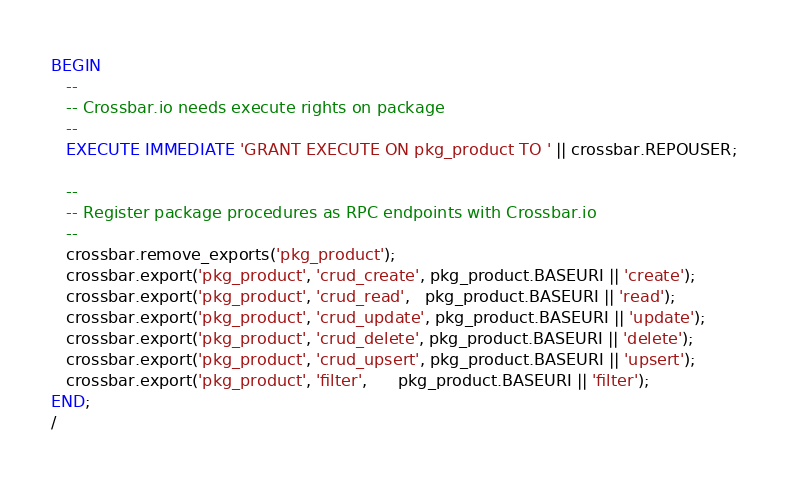<code> <loc_0><loc_0><loc_500><loc_500><_SQL_>BEGIN
   --
   -- Crossbar.io needs execute rights on package
   --
   EXECUTE IMMEDIATE 'GRANT EXECUTE ON pkg_product TO ' || crossbar.REPOUSER;

   --
   -- Register package procedures as RPC endpoints with Crossbar.io
   --
   crossbar.remove_exports('pkg_product');
   crossbar.export('pkg_product', 'crud_create', pkg_product.BASEURI || 'create');
   crossbar.export('pkg_product', 'crud_read',   pkg_product.BASEURI || 'read');
   crossbar.export('pkg_product', 'crud_update', pkg_product.BASEURI || 'update');
   crossbar.export('pkg_product', 'crud_delete', pkg_product.BASEURI || 'delete');
   crossbar.export('pkg_product', 'crud_upsert', pkg_product.BASEURI || 'upsert');
   crossbar.export('pkg_product', 'filter',      pkg_product.BASEURI || 'filter');
END;
/
</code> 